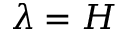<formula> <loc_0><loc_0><loc_500><loc_500>\lambda = H</formula> 